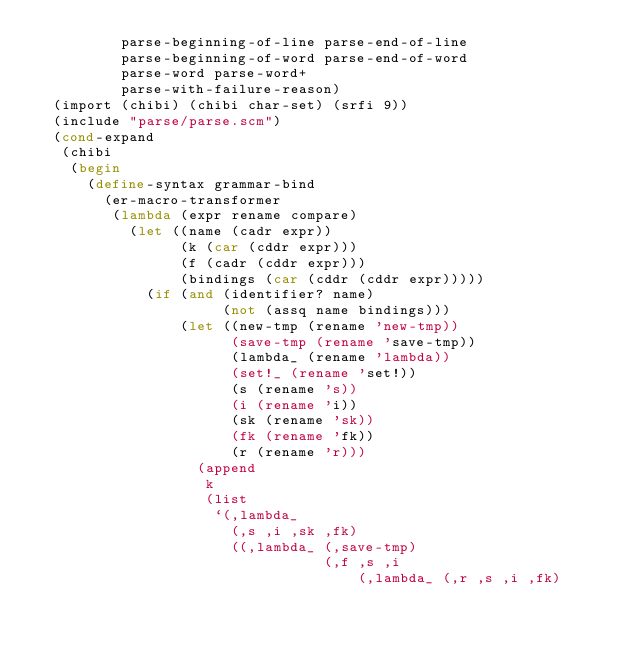Convert code to text. <code><loc_0><loc_0><loc_500><loc_500><_Scheme_>          parse-beginning-of-line parse-end-of-line
          parse-beginning-of-word parse-end-of-word
          parse-word parse-word+
          parse-with-failure-reason)
  (import (chibi) (chibi char-set) (srfi 9))
  (include "parse/parse.scm")
  (cond-expand
   (chibi
    (begin
      (define-syntax grammar-bind
        (er-macro-transformer
         (lambda (expr rename compare)
           (let ((name (cadr expr))
                 (k (car (cddr expr)))
                 (f (cadr (cddr expr)))
                 (bindings (car (cddr (cddr expr)))))
             (if (and (identifier? name)
                      (not (assq name bindings)))
                 (let ((new-tmp (rename 'new-tmp))
                       (save-tmp (rename 'save-tmp))
                       (lambda_ (rename 'lambda))
                       (set!_ (rename 'set!))
                       (s (rename 's))
                       (i (rename 'i))
                       (sk (rename 'sk))
                       (fk (rename 'fk))
                       (r (rename 'r)))
                   (append
                    k
                    (list
                     `(,lambda_
                       (,s ,i ,sk ,fk)
                       ((,lambda_ (,save-tmp)
                                  (,f ,s ,i
                                      (,lambda_ (,r ,s ,i ,fk)</code> 